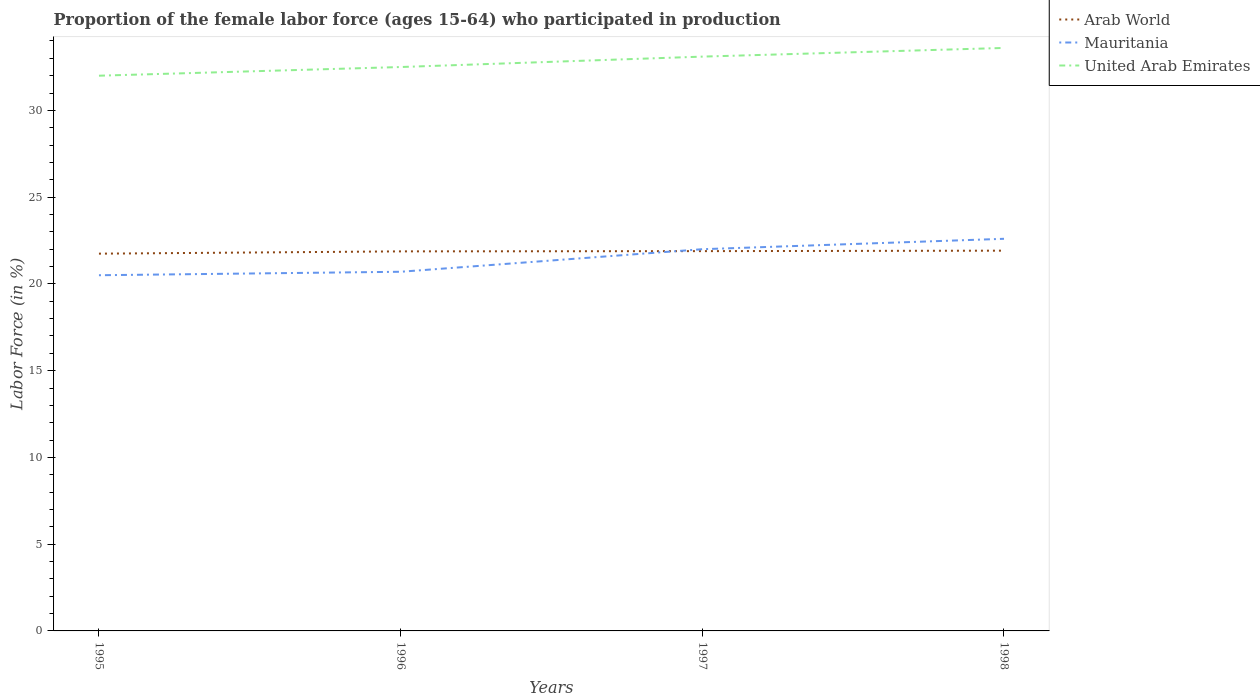Across all years, what is the maximum proportion of the female labor force who participated in production in United Arab Emirates?
Provide a succinct answer. 32. What is the total proportion of the female labor force who participated in production in Arab World in the graph?
Your answer should be very brief. -0.15. What is the difference between the highest and the second highest proportion of the female labor force who participated in production in United Arab Emirates?
Your response must be concise. 1.6. How many lines are there?
Offer a terse response. 3. How many years are there in the graph?
Keep it short and to the point. 4. How many legend labels are there?
Your answer should be very brief. 3. How are the legend labels stacked?
Offer a terse response. Vertical. What is the title of the graph?
Your answer should be compact. Proportion of the female labor force (ages 15-64) who participated in production. Does "Singapore" appear as one of the legend labels in the graph?
Your answer should be compact. No. What is the label or title of the Y-axis?
Your answer should be very brief. Labor Force (in %). What is the Labor Force (in %) in Arab World in 1995?
Offer a very short reply. 21.74. What is the Labor Force (in %) in United Arab Emirates in 1995?
Offer a very short reply. 32. What is the Labor Force (in %) in Arab World in 1996?
Provide a short and direct response. 21.88. What is the Labor Force (in %) of Mauritania in 1996?
Provide a succinct answer. 20.7. What is the Labor Force (in %) of United Arab Emirates in 1996?
Offer a very short reply. 32.5. What is the Labor Force (in %) of Arab World in 1997?
Provide a succinct answer. 21.89. What is the Labor Force (in %) of Mauritania in 1997?
Offer a very short reply. 22. What is the Labor Force (in %) in United Arab Emirates in 1997?
Provide a succinct answer. 33.1. What is the Labor Force (in %) of Arab World in 1998?
Offer a terse response. 21.92. What is the Labor Force (in %) of Mauritania in 1998?
Offer a terse response. 22.6. What is the Labor Force (in %) of United Arab Emirates in 1998?
Your answer should be very brief. 33.6. Across all years, what is the maximum Labor Force (in %) of Arab World?
Keep it short and to the point. 21.92. Across all years, what is the maximum Labor Force (in %) in Mauritania?
Provide a succinct answer. 22.6. Across all years, what is the maximum Labor Force (in %) in United Arab Emirates?
Offer a terse response. 33.6. Across all years, what is the minimum Labor Force (in %) in Arab World?
Provide a succinct answer. 21.74. What is the total Labor Force (in %) in Arab World in the graph?
Provide a succinct answer. 87.42. What is the total Labor Force (in %) in Mauritania in the graph?
Give a very brief answer. 85.8. What is the total Labor Force (in %) in United Arab Emirates in the graph?
Give a very brief answer. 131.2. What is the difference between the Labor Force (in %) in Arab World in 1995 and that in 1996?
Give a very brief answer. -0.13. What is the difference between the Labor Force (in %) of United Arab Emirates in 1995 and that in 1996?
Make the answer very short. -0.5. What is the difference between the Labor Force (in %) in Arab World in 1995 and that in 1997?
Your answer should be compact. -0.15. What is the difference between the Labor Force (in %) in Mauritania in 1995 and that in 1997?
Provide a succinct answer. -1.5. What is the difference between the Labor Force (in %) of Arab World in 1995 and that in 1998?
Offer a very short reply. -0.17. What is the difference between the Labor Force (in %) of Mauritania in 1995 and that in 1998?
Keep it short and to the point. -2.1. What is the difference between the Labor Force (in %) of Arab World in 1996 and that in 1997?
Offer a terse response. -0.01. What is the difference between the Labor Force (in %) of Arab World in 1996 and that in 1998?
Provide a succinct answer. -0.04. What is the difference between the Labor Force (in %) in Mauritania in 1996 and that in 1998?
Offer a terse response. -1.9. What is the difference between the Labor Force (in %) in United Arab Emirates in 1996 and that in 1998?
Keep it short and to the point. -1.1. What is the difference between the Labor Force (in %) of Arab World in 1997 and that in 1998?
Offer a terse response. -0.03. What is the difference between the Labor Force (in %) of Arab World in 1995 and the Labor Force (in %) of Mauritania in 1996?
Keep it short and to the point. 1.04. What is the difference between the Labor Force (in %) in Arab World in 1995 and the Labor Force (in %) in United Arab Emirates in 1996?
Provide a short and direct response. -10.76. What is the difference between the Labor Force (in %) of Arab World in 1995 and the Labor Force (in %) of Mauritania in 1997?
Provide a succinct answer. -0.26. What is the difference between the Labor Force (in %) of Arab World in 1995 and the Labor Force (in %) of United Arab Emirates in 1997?
Keep it short and to the point. -11.36. What is the difference between the Labor Force (in %) in Arab World in 1995 and the Labor Force (in %) in Mauritania in 1998?
Offer a very short reply. -0.86. What is the difference between the Labor Force (in %) in Arab World in 1995 and the Labor Force (in %) in United Arab Emirates in 1998?
Ensure brevity in your answer.  -11.86. What is the difference between the Labor Force (in %) in Arab World in 1996 and the Labor Force (in %) in Mauritania in 1997?
Give a very brief answer. -0.12. What is the difference between the Labor Force (in %) in Arab World in 1996 and the Labor Force (in %) in United Arab Emirates in 1997?
Offer a very short reply. -11.22. What is the difference between the Labor Force (in %) of Arab World in 1996 and the Labor Force (in %) of Mauritania in 1998?
Make the answer very short. -0.72. What is the difference between the Labor Force (in %) of Arab World in 1996 and the Labor Force (in %) of United Arab Emirates in 1998?
Provide a short and direct response. -11.72. What is the difference between the Labor Force (in %) in Mauritania in 1996 and the Labor Force (in %) in United Arab Emirates in 1998?
Your response must be concise. -12.9. What is the difference between the Labor Force (in %) in Arab World in 1997 and the Labor Force (in %) in Mauritania in 1998?
Your response must be concise. -0.71. What is the difference between the Labor Force (in %) of Arab World in 1997 and the Labor Force (in %) of United Arab Emirates in 1998?
Offer a terse response. -11.71. What is the difference between the Labor Force (in %) in Mauritania in 1997 and the Labor Force (in %) in United Arab Emirates in 1998?
Provide a short and direct response. -11.6. What is the average Labor Force (in %) of Arab World per year?
Your answer should be compact. 21.86. What is the average Labor Force (in %) in Mauritania per year?
Ensure brevity in your answer.  21.45. What is the average Labor Force (in %) in United Arab Emirates per year?
Give a very brief answer. 32.8. In the year 1995, what is the difference between the Labor Force (in %) of Arab World and Labor Force (in %) of Mauritania?
Provide a short and direct response. 1.24. In the year 1995, what is the difference between the Labor Force (in %) of Arab World and Labor Force (in %) of United Arab Emirates?
Provide a succinct answer. -10.26. In the year 1996, what is the difference between the Labor Force (in %) in Arab World and Labor Force (in %) in Mauritania?
Make the answer very short. 1.18. In the year 1996, what is the difference between the Labor Force (in %) in Arab World and Labor Force (in %) in United Arab Emirates?
Make the answer very short. -10.62. In the year 1997, what is the difference between the Labor Force (in %) of Arab World and Labor Force (in %) of Mauritania?
Give a very brief answer. -0.11. In the year 1997, what is the difference between the Labor Force (in %) of Arab World and Labor Force (in %) of United Arab Emirates?
Your answer should be very brief. -11.21. In the year 1997, what is the difference between the Labor Force (in %) in Mauritania and Labor Force (in %) in United Arab Emirates?
Make the answer very short. -11.1. In the year 1998, what is the difference between the Labor Force (in %) of Arab World and Labor Force (in %) of Mauritania?
Keep it short and to the point. -0.68. In the year 1998, what is the difference between the Labor Force (in %) in Arab World and Labor Force (in %) in United Arab Emirates?
Provide a short and direct response. -11.68. What is the ratio of the Labor Force (in %) in Mauritania in 1995 to that in 1996?
Make the answer very short. 0.99. What is the ratio of the Labor Force (in %) in United Arab Emirates in 1995 to that in 1996?
Offer a terse response. 0.98. What is the ratio of the Labor Force (in %) of Arab World in 1995 to that in 1997?
Provide a succinct answer. 0.99. What is the ratio of the Labor Force (in %) in Mauritania in 1995 to that in 1997?
Make the answer very short. 0.93. What is the ratio of the Labor Force (in %) in United Arab Emirates in 1995 to that in 1997?
Keep it short and to the point. 0.97. What is the ratio of the Labor Force (in %) in Mauritania in 1995 to that in 1998?
Your response must be concise. 0.91. What is the ratio of the Labor Force (in %) in United Arab Emirates in 1995 to that in 1998?
Provide a succinct answer. 0.95. What is the ratio of the Labor Force (in %) of Arab World in 1996 to that in 1997?
Your answer should be compact. 1. What is the ratio of the Labor Force (in %) of Mauritania in 1996 to that in 1997?
Provide a succinct answer. 0.94. What is the ratio of the Labor Force (in %) of United Arab Emirates in 1996 to that in 1997?
Make the answer very short. 0.98. What is the ratio of the Labor Force (in %) in Arab World in 1996 to that in 1998?
Your answer should be very brief. 1. What is the ratio of the Labor Force (in %) in Mauritania in 1996 to that in 1998?
Offer a very short reply. 0.92. What is the ratio of the Labor Force (in %) of United Arab Emirates in 1996 to that in 1998?
Your answer should be compact. 0.97. What is the ratio of the Labor Force (in %) of Arab World in 1997 to that in 1998?
Make the answer very short. 1. What is the ratio of the Labor Force (in %) in Mauritania in 1997 to that in 1998?
Provide a short and direct response. 0.97. What is the ratio of the Labor Force (in %) in United Arab Emirates in 1997 to that in 1998?
Your answer should be very brief. 0.99. What is the difference between the highest and the second highest Labor Force (in %) of Arab World?
Give a very brief answer. 0.03. What is the difference between the highest and the second highest Labor Force (in %) in United Arab Emirates?
Give a very brief answer. 0.5. What is the difference between the highest and the lowest Labor Force (in %) of Arab World?
Provide a short and direct response. 0.17. What is the difference between the highest and the lowest Labor Force (in %) in Mauritania?
Ensure brevity in your answer.  2.1. What is the difference between the highest and the lowest Labor Force (in %) in United Arab Emirates?
Provide a succinct answer. 1.6. 